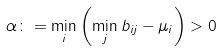Convert formula to latex. <formula><loc_0><loc_0><loc_500><loc_500>\alpha \colon = \min _ { i } \left ( \min _ { j } b _ { i j } - \mu _ { i } \right ) > 0</formula> 